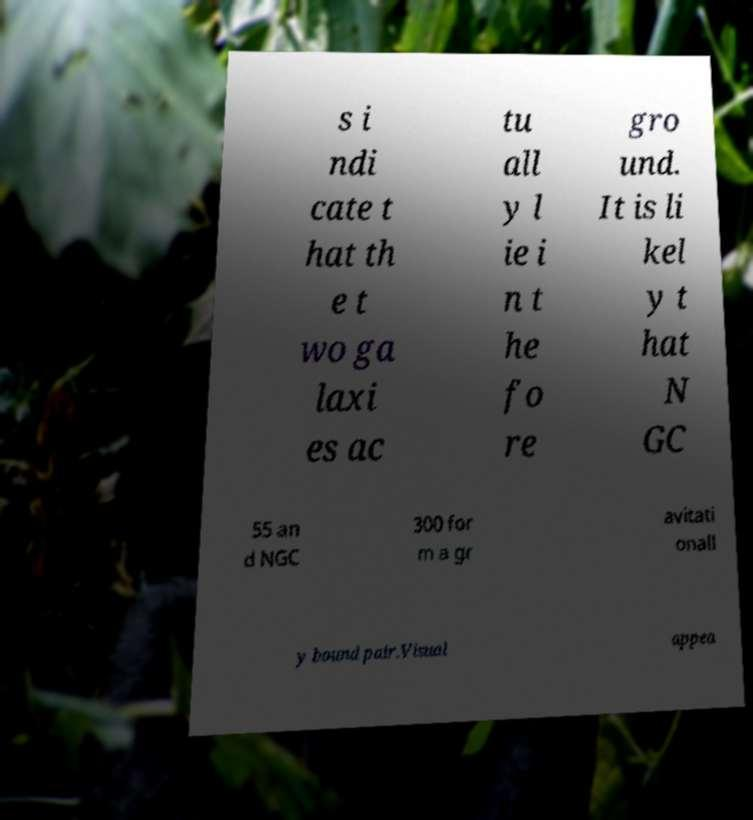Please read and relay the text visible in this image. What does it say? s i ndi cate t hat th e t wo ga laxi es ac tu all y l ie i n t he fo re gro und. It is li kel y t hat N GC 55 an d NGC 300 for m a gr avitati onall y bound pair.Visual appea 